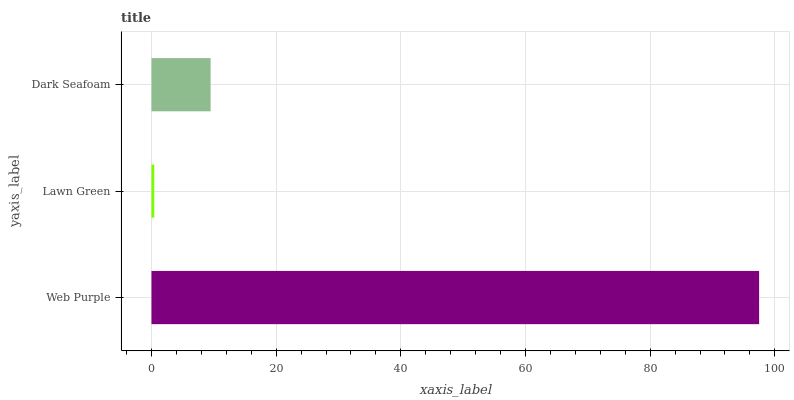Is Lawn Green the minimum?
Answer yes or no. Yes. Is Web Purple the maximum?
Answer yes or no. Yes. Is Dark Seafoam the minimum?
Answer yes or no. No. Is Dark Seafoam the maximum?
Answer yes or no. No. Is Dark Seafoam greater than Lawn Green?
Answer yes or no. Yes. Is Lawn Green less than Dark Seafoam?
Answer yes or no. Yes. Is Lawn Green greater than Dark Seafoam?
Answer yes or no. No. Is Dark Seafoam less than Lawn Green?
Answer yes or no. No. Is Dark Seafoam the high median?
Answer yes or no. Yes. Is Dark Seafoam the low median?
Answer yes or no. Yes. Is Web Purple the high median?
Answer yes or no. No. Is Web Purple the low median?
Answer yes or no. No. 